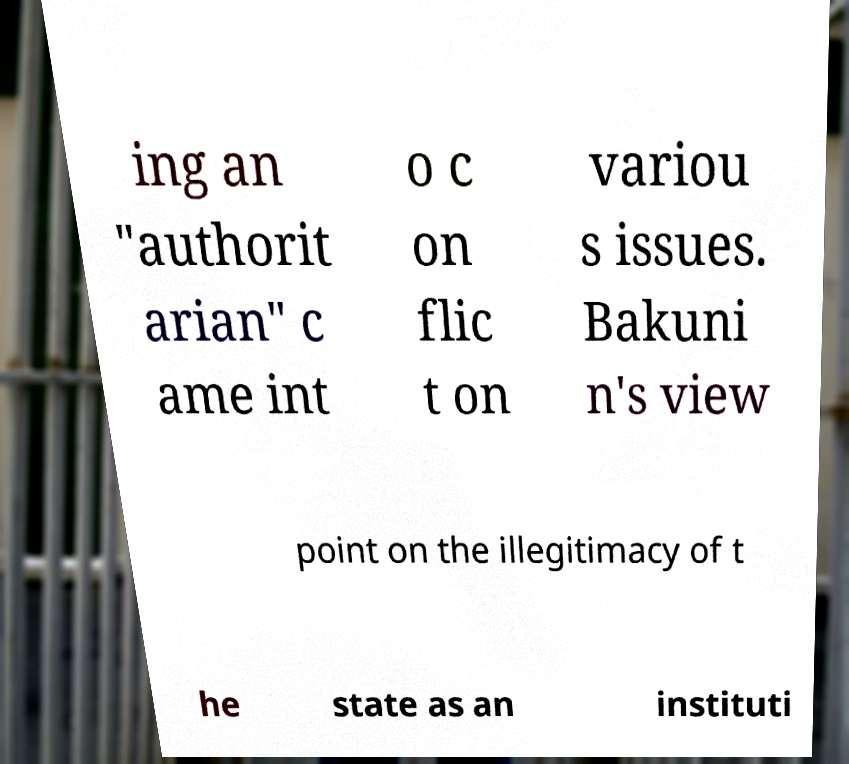Can you read and provide the text displayed in the image?This photo seems to have some interesting text. Can you extract and type it out for me? ing an "authorit arian" c ame int o c on flic t on variou s issues. Bakuni n's view point on the illegitimacy of t he state as an instituti 